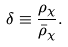Convert formula to latex. <formula><loc_0><loc_0><loc_500><loc_500>\delta \equiv \frac { \rho _ { \chi } } { \bar { \rho } _ { \chi } } .</formula> 